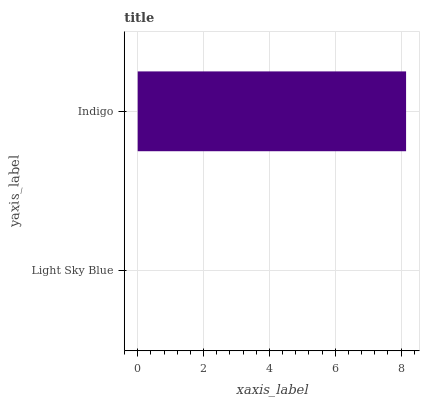Is Light Sky Blue the minimum?
Answer yes or no. Yes. Is Indigo the maximum?
Answer yes or no. Yes. Is Indigo the minimum?
Answer yes or no. No. Is Indigo greater than Light Sky Blue?
Answer yes or no. Yes. Is Light Sky Blue less than Indigo?
Answer yes or no. Yes. Is Light Sky Blue greater than Indigo?
Answer yes or no. No. Is Indigo less than Light Sky Blue?
Answer yes or no. No. Is Indigo the high median?
Answer yes or no. Yes. Is Light Sky Blue the low median?
Answer yes or no. Yes. Is Light Sky Blue the high median?
Answer yes or no. No. Is Indigo the low median?
Answer yes or no. No. 